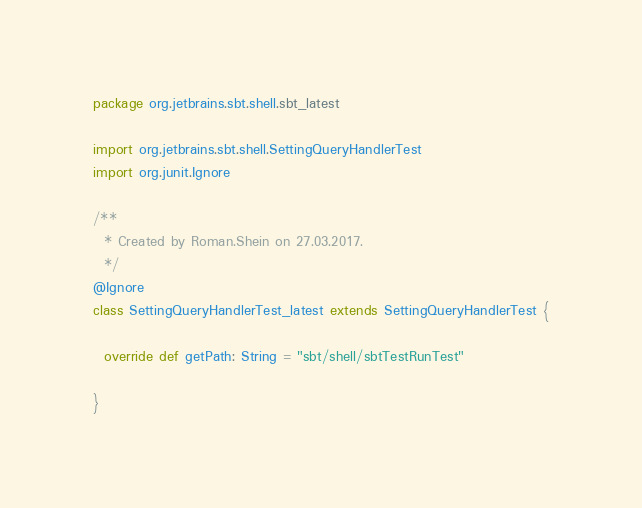Convert code to text. <code><loc_0><loc_0><loc_500><loc_500><_Scala_>package org.jetbrains.sbt.shell.sbt_latest

import org.jetbrains.sbt.shell.SettingQueryHandlerTest
import org.junit.Ignore

/**
  * Created by Roman.Shein on 27.03.2017.
  */
@Ignore
class SettingQueryHandlerTest_latest extends SettingQueryHandlerTest {

  override def getPath: String = "sbt/shell/sbtTestRunTest"

}</code> 